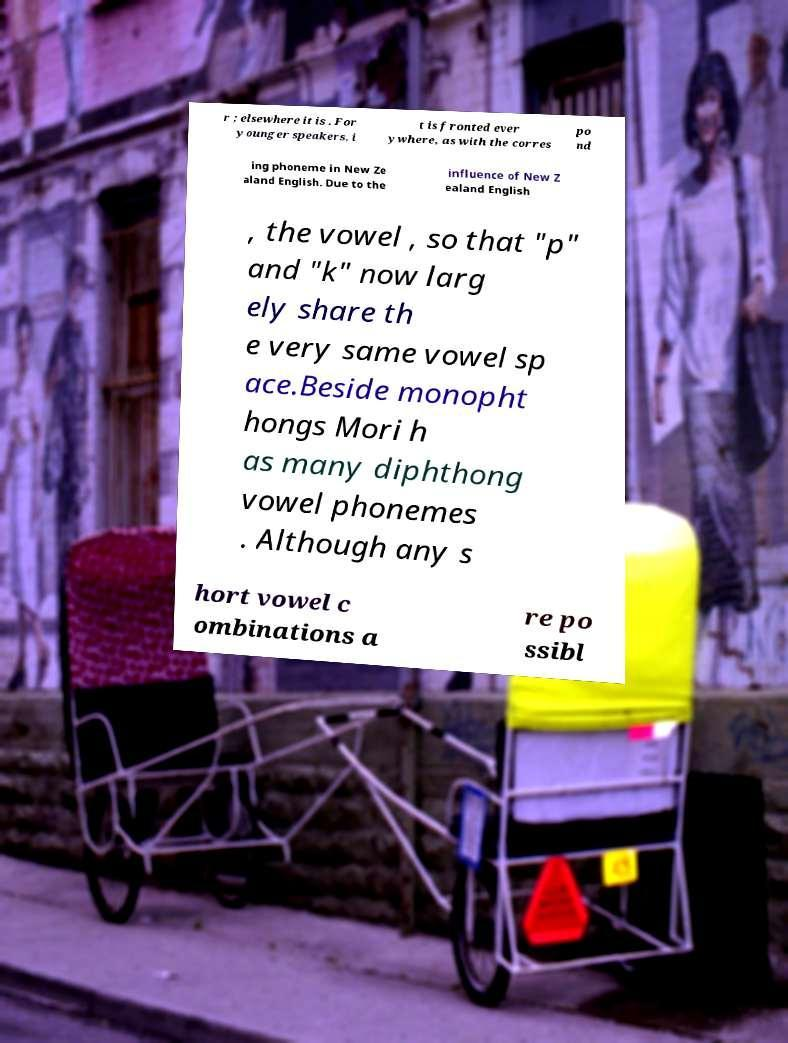Can you accurately transcribe the text from the provided image for me? r ; elsewhere it is . For younger speakers, i t is fronted ever ywhere, as with the corres po nd ing phoneme in New Ze aland English. Due to the influence of New Z ealand English , the vowel , so that "p" and "k" now larg ely share th e very same vowel sp ace.Beside monopht hongs Mori h as many diphthong vowel phonemes . Although any s hort vowel c ombinations a re po ssibl 